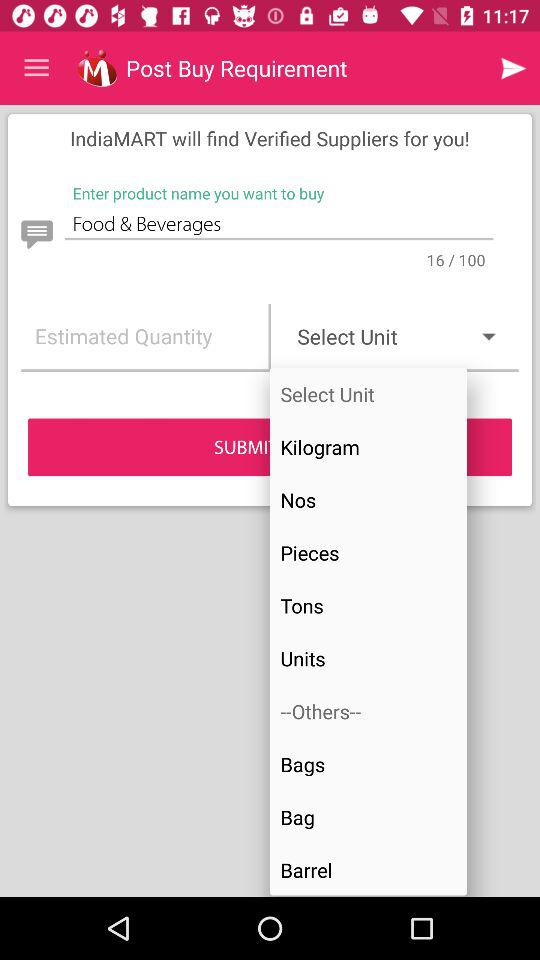What is the product name? The product name is "Food & Beverages". 